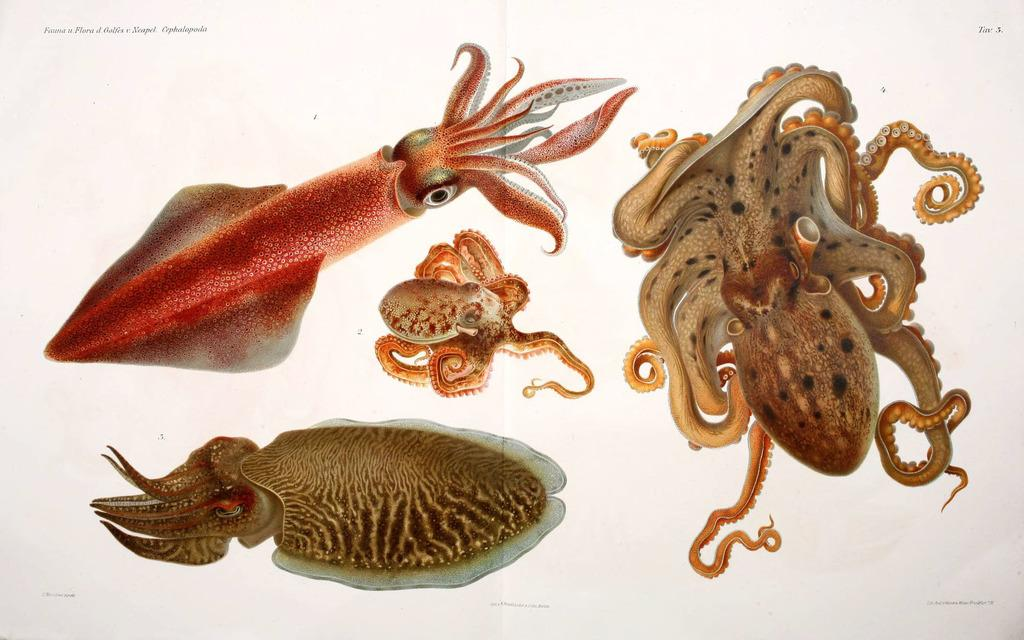What types of marine animals are featured in the image? There are different types of cephalopods in the image. Is there any additional information provided on the image? Yes, there is text on the image. How does the beetle compare to the cephalopods in the image? There is no beetle present in the image; it only features different types of cephalopods. What type of writing style is used in the prose on the image? There is no prose present in the image; it only contains text and images of cephalopods. 